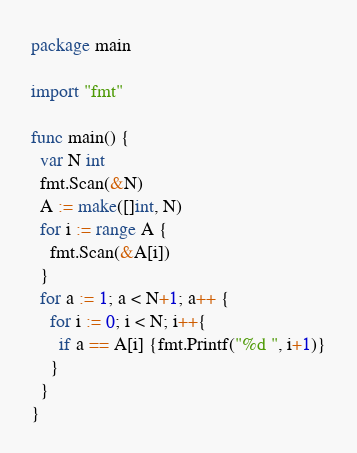<code> <loc_0><loc_0><loc_500><loc_500><_Go_>package main

import "fmt"

func main() {
  var N int
  fmt.Scan(&N)
  A := make([]int, N)
  for i := range A {
    fmt.Scan(&A[i])
  }
  for a := 1; a < N+1; a++ {
    for i := 0; i < N; i++{
      if a == A[i] {fmt.Printf("%d ", i+1)}
    }
  }
}
</code> 